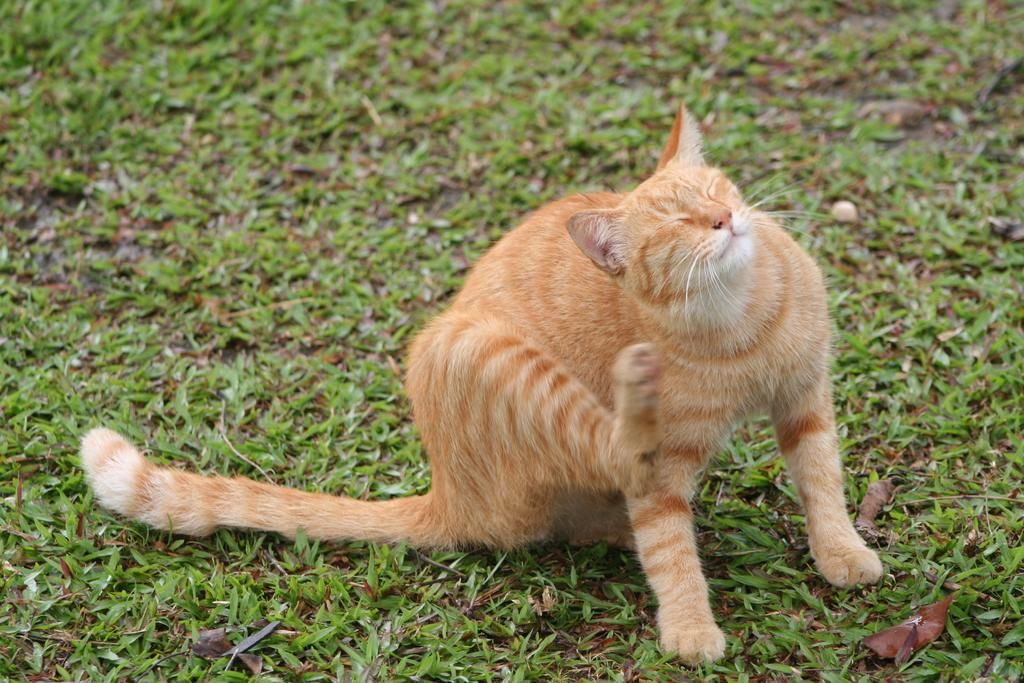What type of animal is in the image? There is a cat in the image. What type of vegetation is present in the image? There is grass in the image. How many cows are visible in the image? There are no cows present in the image; it features a cat and grass. What type of hook is being used by the cat in the image? There is no hook present in the image; it features a cat and grass. 